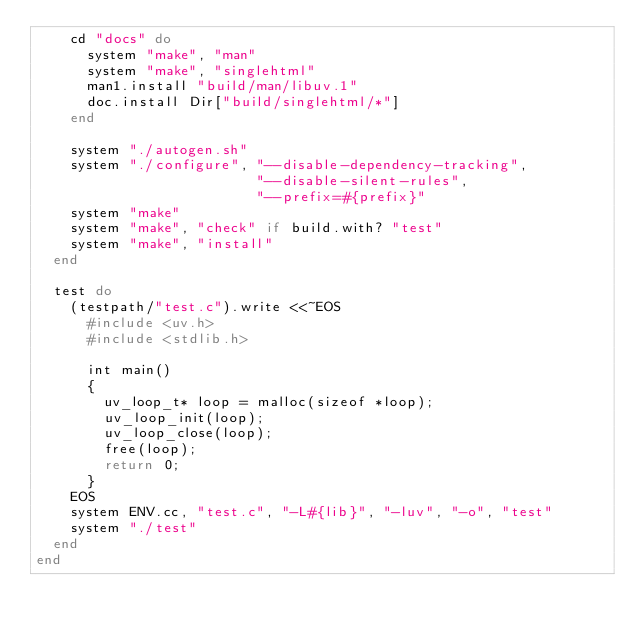Convert code to text. <code><loc_0><loc_0><loc_500><loc_500><_Ruby_>    cd "docs" do
      system "make", "man"
      system "make", "singlehtml"
      man1.install "build/man/libuv.1"
      doc.install Dir["build/singlehtml/*"]
    end

    system "./autogen.sh"
    system "./configure", "--disable-dependency-tracking",
                          "--disable-silent-rules",
                          "--prefix=#{prefix}"
    system "make"
    system "make", "check" if build.with? "test"
    system "make", "install"
  end

  test do
    (testpath/"test.c").write <<~EOS
      #include <uv.h>
      #include <stdlib.h>

      int main()
      {
        uv_loop_t* loop = malloc(sizeof *loop);
        uv_loop_init(loop);
        uv_loop_close(loop);
        free(loop);
        return 0;
      }
    EOS
    system ENV.cc, "test.c", "-L#{lib}", "-luv", "-o", "test"
    system "./test"
  end
end
</code> 